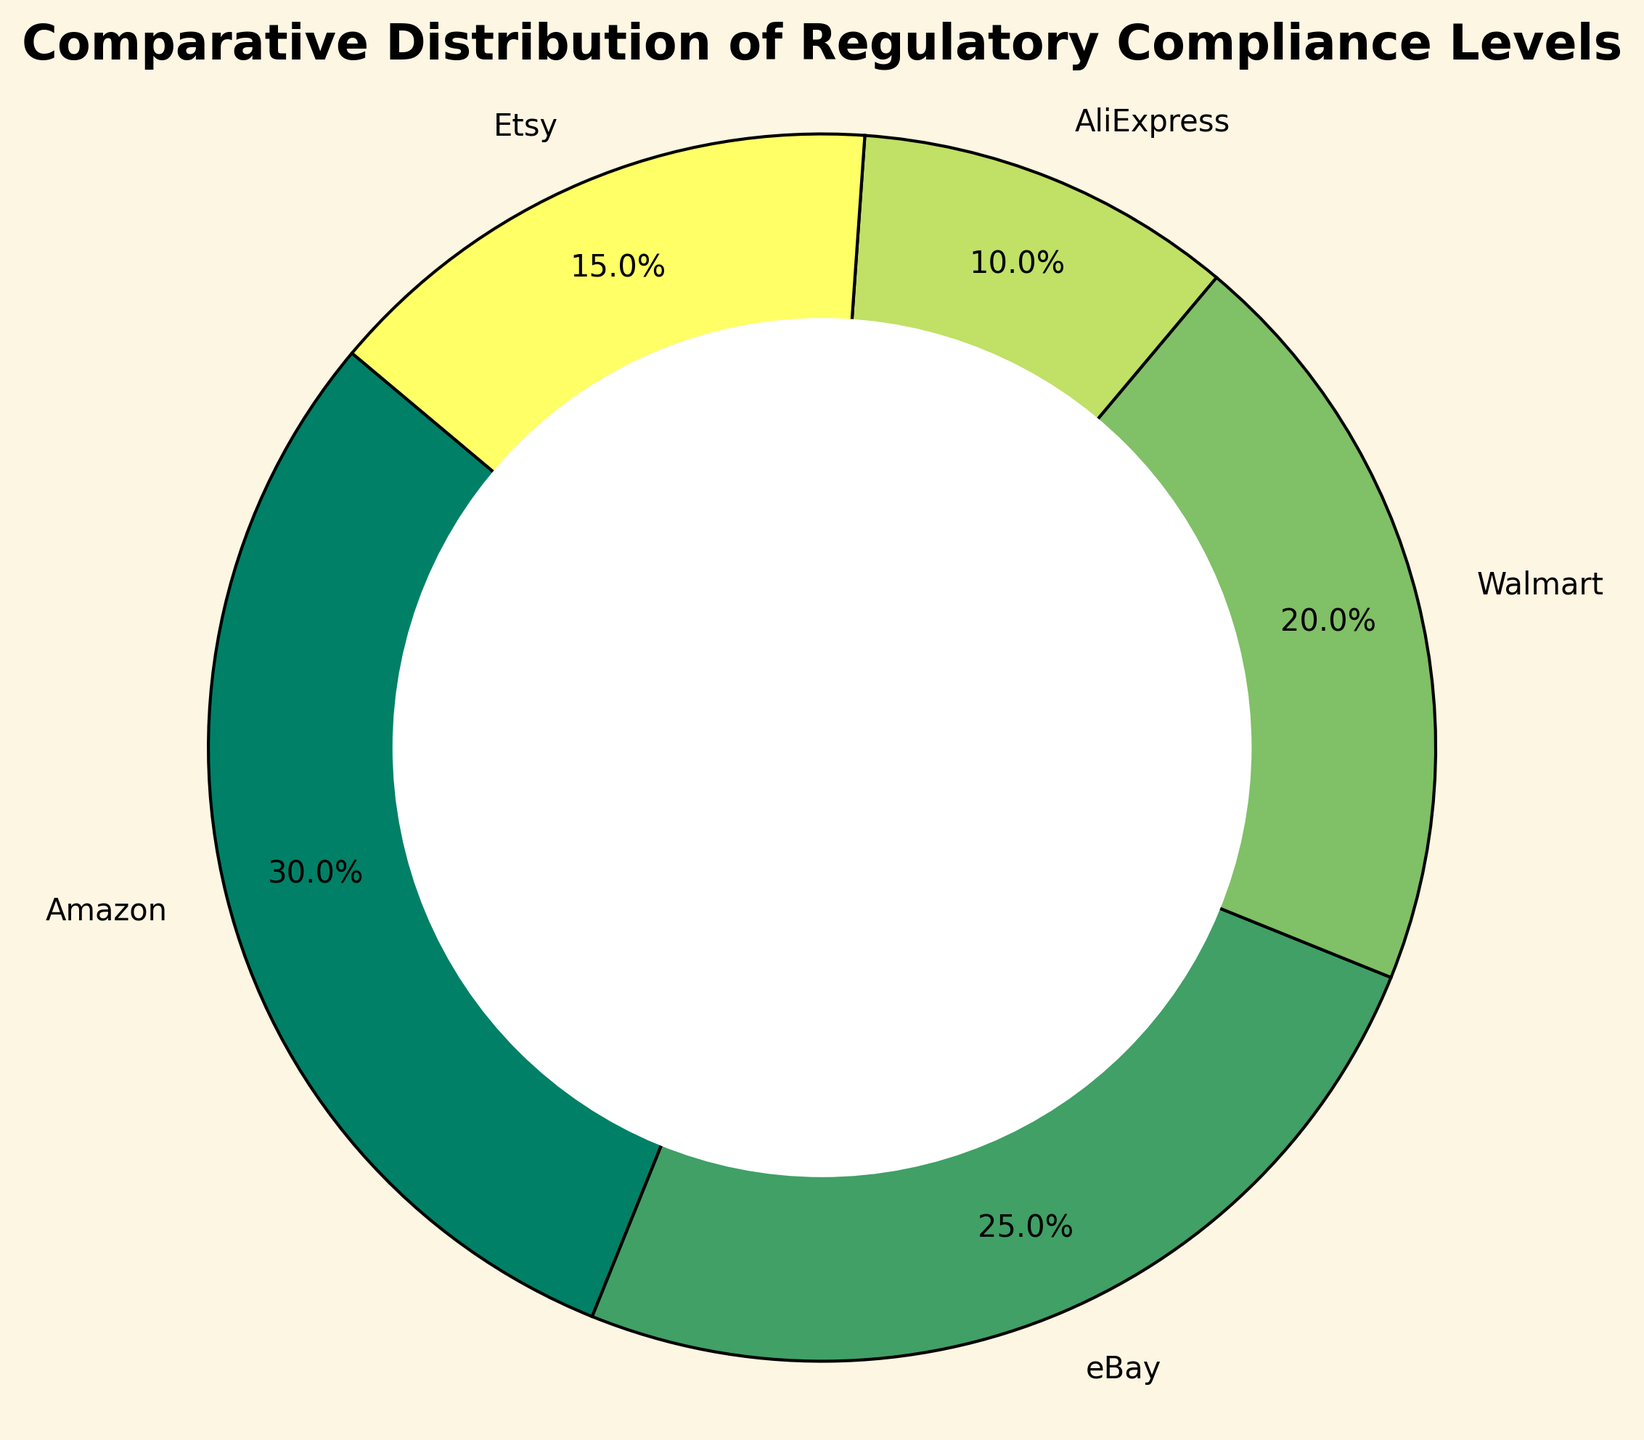What's the percentage of platforms with high compliance levels? To find the percentage of platforms with high compliance levels, sum the percentages of Amazon (30%) and Walmart (20%). The total is 30 + 20 = 50%.
Answer: 50% Which platform has the lowest regulatory compliance level? AliExpress has only 10%, which is the lowest among the listed platforms.
Answer: AliExpress What is the combined percentage of platforms with moderate compliance levels? Add the percentages of eBay (25%) and Etsy (15%). The combined percentage is 25 + 15 = 40%.
Answer: 40% What is the difference between the highest and lowest compliance levels? The highest compliance level is Amazon's 30%, and the lowest is AliExpress' 10%. The difference is 30 - 10 = 20%.
Answer: 20% Which two platforms together make up exactly half of the compliance levels in the chart? Amazon (30%) and Walmart (20%) together make up 30 + 20 = 50%.
Answer: Amazon and Walmart How does the compliance level of Etsy compare to that of Walmart? Etsy has 15% compliance while Walmart has 20%. Walmart's compliance is higher by 20% - 15% = 5%.
Answer: Walmart's compliance is higher by 5% If the chart were to represent regulatory efforts instead, which platform would need the most improvement? AliExpress has the lowest percentage of compliance levels at 10%, indicating the most room for improvement in regulatory efforts.
Answer: AliExpress What percentage of platforms have compliance levels above 20%? Amazon (30%) and eBay (25%) have compliance levels above 20%. Together, they account for 30% + 25% = 55%.
Answer: 55% Is there a significant difference in compliance levels between the highest and the average of the moderate compliance levels? The highest compliance level is 30% (Amazon). The average moderate compliance level is (25% + 15%)/2 = 20%. The difference is 30 - 20 = 10%.
Answer: 10% What can be inferred about AliExpress's compliance level in comparison to the average of all the other platforms? The average compliance level of the other platforms is (30 + 25 + 20 + 15)/4 = 22.5%. AliExpress’s 10% is significantly lower than this average.
Answer: AliExpress is significantly lower than the average 